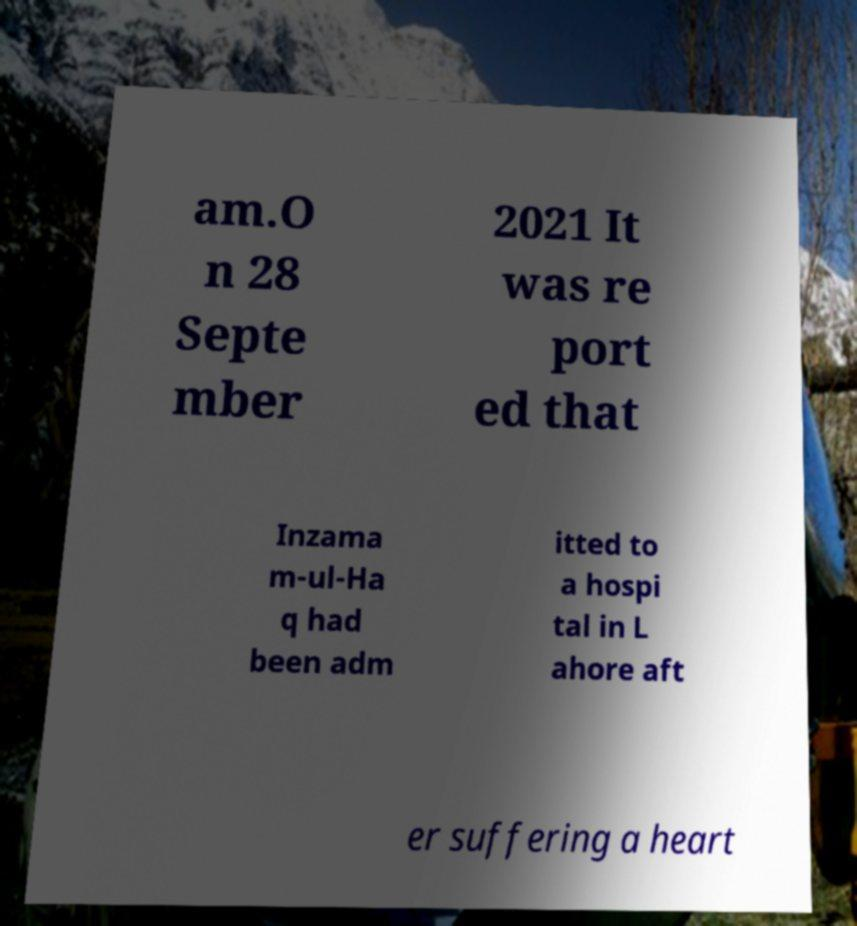Could you assist in decoding the text presented in this image and type it out clearly? am.O n 28 Septe mber 2021 It was re port ed that Inzama m-ul-Ha q had been adm itted to a hospi tal in L ahore aft er suffering a heart 